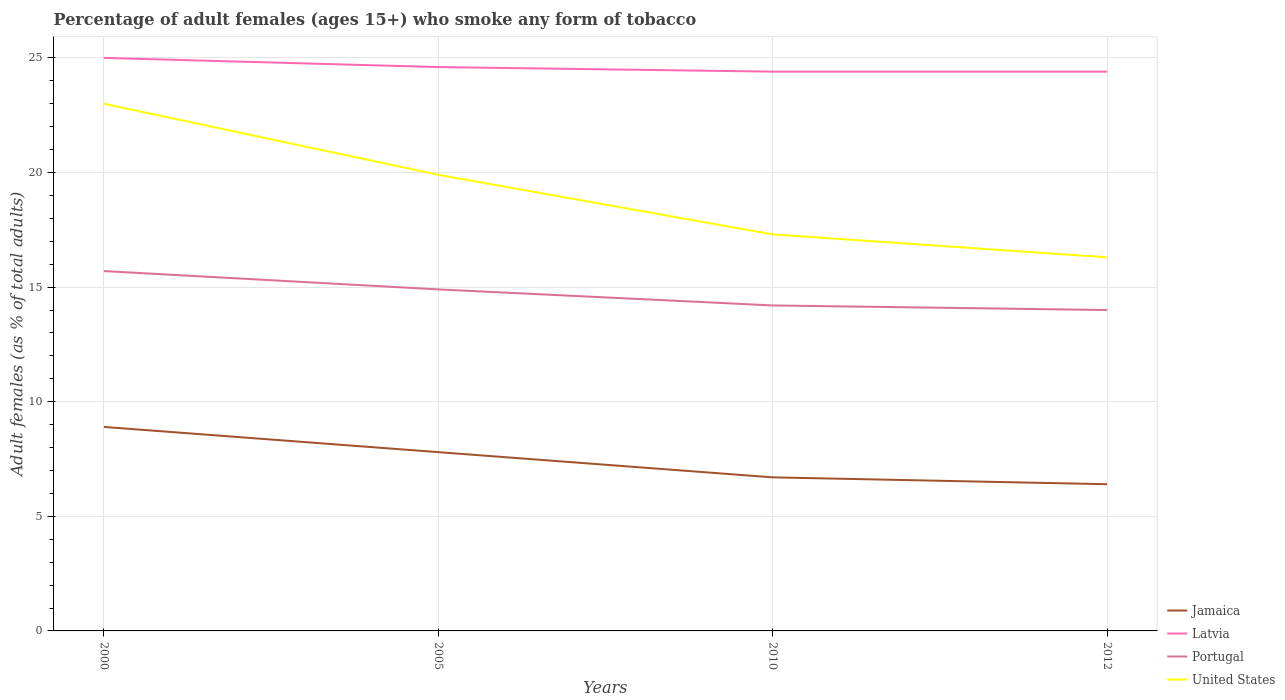What is the total percentage of adult females who smoke in Jamaica in the graph?
Keep it short and to the point. 1.1. Is the percentage of adult females who smoke in United States strictly greater than the percentage of adult females who smoke in Jamaica over the years?
Your answer should be very brief. No. How many years are there in the graph?
Give a very brief answer. 4. Does the graph contain any zero values?
Ensure brevity in your answer.  No. Does the graph contain grids?
Make the answer very short. Yes. How many legend labels are there?
Provide a succinct answer. 4. What is the title of the graph?
Ensure brevity in your answer.  Percentage of adult females (ages 15+) who smoke any form of tobacco. What is the label or title of the Y-axis?
Offer a very short reply. Adult females (as % of total adults). What is the Adult females (as % of total adults) of Jamaica in 2000?
Offer a terse response. 8.9. What is the Adult females (as % of total adults) of Latvia in 2000?
Ensure brevity in your answer.  25. What is the Adult females (as % of total adults) in Portugal in 2000?
Keep it short and to the point. 15.7. What is the Adult females (as % of total adults) of Latvia in 2005?
Offer a very short reply. 24.6. What is the Adult females (as % of total adults) in United States in 2005?
Ensure brevity in your answer.  19.9. What is the Adult females (as % of total adults) in Latvia in 2010?
Keep it short and to the point. 24.4. What is the Adult females (as % of total adults) in Portugal in 2010?
Offer a very short reply. 14.2. What is the Adult females (as % of total adults) in United States in 2010?
Your answer should be compact. 17.3. What is the Adult females (as % of total adults) in Jamaica in 2012?
Offer a terse response. 6.4. What is the Adult females (as % of total adults) in Latvia in 2012?
Provide a short and direct response. 24.4. What is the Adult females (as % of total adults) of United States in 2012?
Provide a short and direct response. 16.3. Across all years, what is the maximum Adult females (as % of total adults) of Latvia?
Your response must be concise. 25. Across all years, what is the maximum Adult females (as % of total adults) of Portugal?
Your answer should be compact. 15.7. Across all years, what is the maximum Adult females (as % of total adults) of United States?
Your response must be concise. 23. Across all years, what is the minimum Adult females (as % of total adults) of Jamaica?
Provide a short and direct response. 6.4. Across all years, what is the minimum Adult females (as % of total adults) in Latvia?
Your response must be concise. 24.4. Across all years, what is the minimum Adult females (as % of total adults) of United States?
Give a very brief answer. 16.3. What is the total Adult females (as % of total adults) of Jamaica in the graph?
Give a very brief answer. 29.8. What is the total Adult females (as % of total adults) in Latvia in the graph?
Provide a short and direct response. 98.4. What is the total Adult females (as % of total adults) of Portugal in the graph?
Your answer should be compact. 58.8. What is the total Adult females (as % of total adults) in United States in the graph?
Make the answer very short. 76.5. What is the difference between the Adult females (as % of total adults) of Latvia in 2000 and that in 2005?
Provide a succinct answer. 0.4. What is the difference between the Adult females (as % of total adults) in Jamaica in 2000 and that in 2010?
Provide a succinct answer. 2.2. What is the difference between the Adult females (as % of total adults) of Portugal in 2000 and that in 2010?
Give a very brief answer. 1.5. What is the difference between the Adult females (as % of total adults) of Latvia in 2000 and that in 2012?
Offer a terse response. 0.6. What is the difference between the Adult females (as % of total adults) of United States in 2000 and that in 2012?
Offer a very short reply. 6.7. What is the difference between the Adult females (as % of total adults) of Jamaica in 2005 and that in 2010?
Provide a succinct answer. 1.1. What is the difference between the Adult females (as % of total adults) in Latvia in 2005 and that in 2010?
Your response must be concise. 0.2. What is the difference between the Adult females (as % of total adults) in Jamaica in 2005 and that in 2012?
Offer a terse response. 1.4. What is the difference between the Adult females (as % of total adults) of Portugal in 2005 and that in 2012?
Keep it short and to the point. 0.9. What is the difference between the Adult females (as % of total adults) of Jamaica in 2010 and that in 2012?
Your answer should be compact. 0.3. What is the difference between the Adult females (as % of total adults) in Jamaica in 2000 and the Adult females (as % of total adults) in Latvia in 2005?
Provide a short and direct response. -15.7. What is the difference between the Adult females (as % of total adults) of Jamaica in 2000 and the Adult females (as % of total adults) of United States in 2005?
Offer a very short reply. -11. What is the difference between the Adult females (as % of total adults) in Latvia in 2000 and the Adult females (as % of total adults) in United States in 2005?
Give a very brief answer. 5.1. What is the difference between the Adult females (as % of total adults) of Jamaica in 2000 and the Adult females (as % of total adults) of Latvia in 2010?
Keep it short and to the point. -15.5. What is the difference between the Adult females (as % of total adults) of Jamaica in 2000 and the Adult females (as % of total adults) of United States in 2010?
Give a very brief answer. -8.4. What is the difference between the Adult females (as % of total adults) of Latvia in 2000 and the Adult females (as % of total adults) of Portugal in 2010?
Your response must be concise. 10.8. What is the difference between the Adult females (as % of total adults) of Latvia in 2000 and the Adult females (as % of total adults) of United States in 2010?
Your answer should be very brief. 7.7. What is the difference between the Adult females (as % of total adults) of Portugal in 2000 and the Adult females (as % of total adults) of United States in 2010?
Ensure brevity in your answer.  -1.6. What is the difference between the Adult females (as % of total adults) of Jamaica in 2000 and the Adult females (as % of total adults) of Latvia in 2012?
Offer a very short reply. -15.5. What is the difference between the Adult females (as % of total adults) in Portugal in 2000 and the Adult females (as % of total adults) in United States in 2012?
Offer a very short reply. -0.6. What is the difference between the Adult females (as % of total adults) in Jamaica in 2005 and the Adult females (as % of total adults) in Latvia in 2010?
Provide a short and direct response. -16.6. What is the difference between the Adult females (as % of total adults) of Jamaica in 2005 and the Adult females (as % of total adults) of Portugal in 2010?
Keep it short and to the point. -6.4. What is the difference between the Adult females (as % of total adults) in Jamaica in 2005 and the Adult females (as % of total adults) in United States in 2010?
Your answer should be compact. -9.5. What is the difference between the Adult females (as % of total adults) in Latvia in 2005 and the Adult females (as % of total adults) in Portugal in 2010?
Your response must be concise. 10.4. What is the difference between the Adult females (as % of total adults) in Latvia in 2005 and the Adult females (as % of total adults) in United States in 2010?
Keep it short and to the point. 7.3. What is the difference between the Adult females (as % of total adults) in Jamaica in 2005 and the Adult females (as % of total adults) in Latvia in 2012?
Offer a terse response. -16.6. What is the difference between the Adult females (as % of total adults) in Jamaica in 2005 and the Adult females (as % of total adults) in United States in 2012?
Keep it short and to the point. -8.5. What is the difference between the Adult females (as % of total adults) in Jamaica in 2010 and the Adult females (as % of total adults) in Latvia in 2012?
Your answer should be very brief. -17.7. What is the difference between the Adult females (as % of total adults) of Jamaica in 2010 and the Adult females (as % of total adults) of United States in 2012?
Offer a very short reply. -9.6. What is the difference between the Adult females (as % of total adults) of Latvia in 2010 and the Adult females (as % of total adults) of Portugal in 2012?
Keep it short and to the point. 10.4. What is the difference between the Adult females (as % of total adults) of Portugal in 2010 and the Adult females (as % of total adults) of United States in 2012?
Your answer should be very brief. -2.1. What is the average Adult females (as % of total adults) of Jamaica per year?
Ensure brevity in your answer.  7.45. What is the average Adult females (as % of total adults) in Latvia per year?
Give a very brief answer. 24.6. What is the average Adult females (as % of total adults) in United States per year?
Offer a very short reply. 19.12. In the year 2000, what is the difference between the Adult females (as % of total adults) in Jamaica and Adult females (as % of total adults) in Latvia?
Provide a succinct answer. -16.1. In the year 2000, what is the difference between the Adult females (as % of total adults) of Jamaica and Adult females (as % of total adults) of Portugal?
Your response must be concise. -6.8. In the year 2000, what is the difference between the Adult females (as % of total adults) in Jamaica and Adult females (as % of total adults) in United States?
Give a very brief answer. -14.1. In the year 2000, what is the difference between the Adult females (as % of total adults) of Latvia and Adult females (as % of total adults) of Portugal?
Give a very brief answer. 9.3. In the year 2005, what is the difference between the Adult females (as % of total adults) of Jamaica and Adult females (as % of total adults) of Latvia?
Make the answer very short. -16.8. In the year 2005, what is the difference between the Adult females (as % of total adults) of Latvia and Adult females (as % of total adults) of Portugal?
Your answer should be compact. 9.7. In the year 2005, what is the difference between the Adult females (as % of total adults) in Portugal and Adult females (as % of total adults) in United States?
Offer a terse response. -5. In the year 2010, what is the difference between the Adult females (as % of total adults) in Jamaica and Adult females (as % of total adults) in Latvia?
Your answer should be compact. -17.7. In the year 2010, what is the difference between the Adult females (as % of total adults) of Jamaica and Adult females (as % of total adults) of Portugal?
Your answer should be compact. -7.5. In the year 2010, what is the difference between the Adult females (as % of total adults) in Portugal and Adult females (as % of total adults) in United States?
Provide a short and direct response. -3.1. In the year 2012, what is the difference between the Adult females (as % of total adults) in Jamaica and Adult females (as % of total adults) in Portugal?
Your response must be concise. -7.6. In the year 2012, what is the difference between the Adult females (as % of total adults) in Latvia and Adult females (as % of total adults) in Portugal?
Provide a short and direct response. 10.4. What is the ratio of the Adult females (as % of total adults) of Jamaica in 2000 to that in 2005?
Provide a short and direct response. 1.14. What is the ratio of the Adult females (as % of total adults) of Latvia in 2000 to that in 2005?
Your response must be concise. 1.02. What is the ratio of the Adult females (as % of total adults) in Portugal in 2000 to that in 2005?
Keep it short and to the point. 1.05. What is the ratio of the Adult females (as % of total adults) of United States in 2000 to that in 2005?
Your answer should be very brief. 1.16. What is the ratio of the Adult females (as % of total adults) of Jamaica in 2000 to that in 2010?
Offer a terse response. 1.33. What is the ratio of the Adult females (as % of total adults) of Latvia in 2000 to that in 2010?
Provide a succinct answer. 1.02. What is the ratio of the Adult females (as % of total adults) in Portugal in 2000 to that in 2010?
Offer a terse response. 1.11. What is the ratio of the Adult females (as % of total adults) of United States in 2000 to that in 2010?
Give a very brief answer. 1.33. What is the ratio of the Adult females (as % of total adults) in Jamaica in 2000 to that in 2012?
Your answer should be very brief. 1.39. What is the ratio of the Adult females (as % of total adults) of Latvia in 2000 to that in 2012?
Make the answer very short. 1.02. What is the ratio of the Adult females (as % of total adults) in Portugal in 2000 to that in 2012?
Your answer should be compact. 1.12. What is the ratio of the Adult females (as % of total adults) of United States in 2000 to that in 2012?
Your response must be concise. 1.41. What is the ratio of the Adult females (as % of total adults) in Jamaica in 2005 to that in 2010?
Your answer should be very brief. 1.16. What is the ratio of the Adult females (as % of total adults) of Latvia in 2005 to that in 2010?
Your answer should be very brief. 1.01. What is the ratio of the Adult females (as % of total adults) of Portugal in 2005 to that in 2010?
Give a very brief answer. 1.05. What is the ratio of the Adult females (as % of total adults) in United States in 2005 to that in 2010?
Your answer should be very brief. 1.15. What is the ratio of the Adult females (as % of total adults) in Jamaica in 2005 to that in 2012?
Provide a short and direct response. 1.22. What is the ratio of the Adult females (as % of total adults) in Latvia in 2005 to that in 2012?
Ensure brevity in your answer.  1.01. What is the ratio of the Adult females (as % of total adults) of Portugal in 2005 to that in 2012?
Keep it short and to the point. 1.06. What is the ratio of the Adult females (as % of total adults) of United States in 2005 to that in 2012?
Ensure brevity in your answer.  1.22. What is the ratio of the Adult females (as % of total adults) in Jamaica in 2010 to that in 2012?
Provide a succinct answer. 1.05. What is the ratio of the Adult females (as % of total adults) in Portugal in 2010 to that in 2012?
Give a very brief answer. 1.01. What is the ratio of the Adult females (as % of total adults) of United States in 2010 to that in 2012?
Keep it short and to the point. 1.06. What is the difference between the highest and the second highest Adult females (as % of total adults) in Jamaica?
Keep it short and to the point. 1.1. What is the difference between the highest and the second highest Adult females (as % of total adults) of Portugal?
Provide a short and direct response. 0.8. What is the difference between the highest and the lowest Adult females (as % of total adults) in Jamaica?
Your response must be concise. 2.5. What is the difference between the highest and the lowest Adult females (as % of total adults) of Latvia?
Your answer should be very brief. 0.6. 